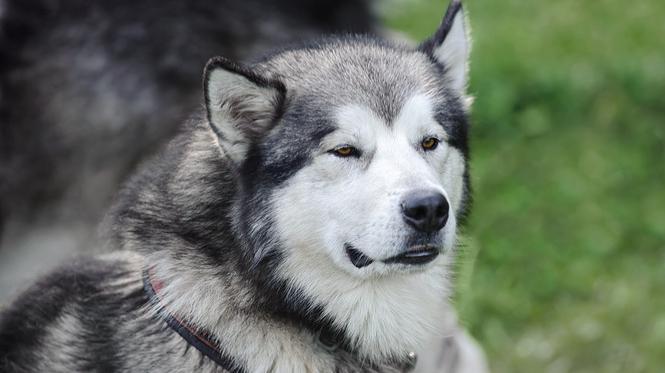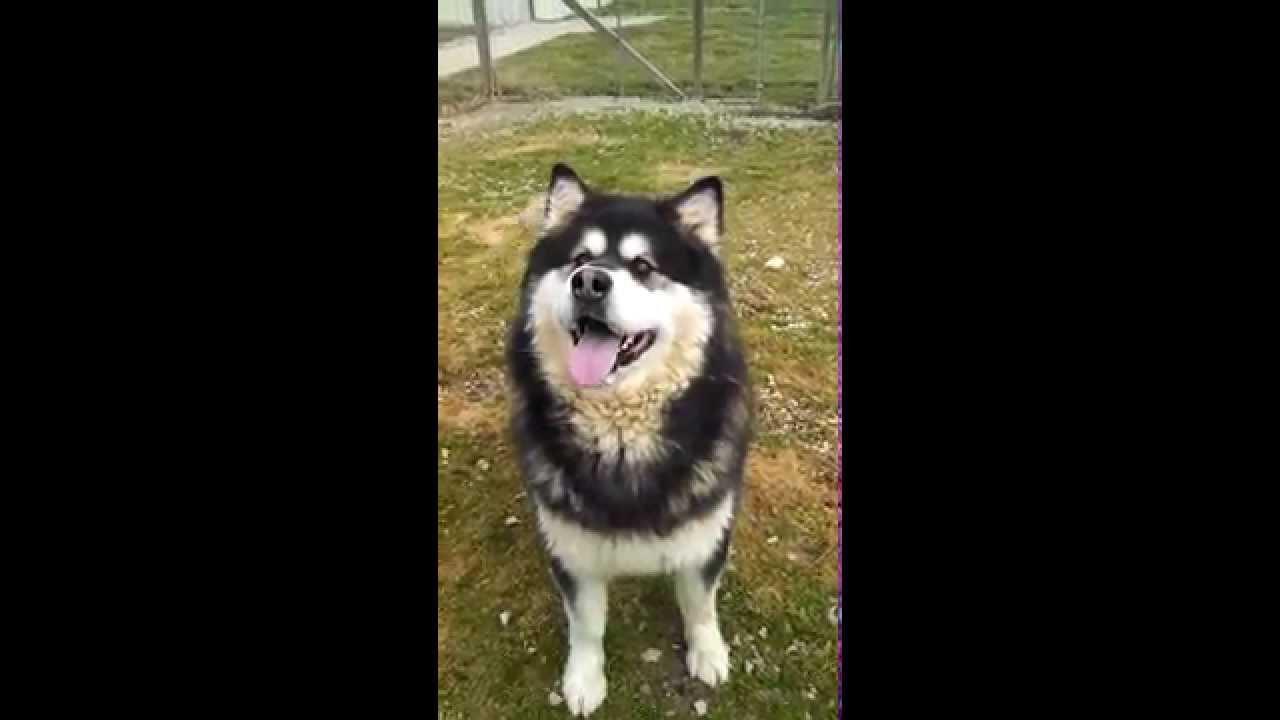The first image is the image on the left, the second image is the image on the right. Given the left and right images, does the statement "At least one dog is standing on grass." hold true? Answer yes or no. Yes. The first image is the image on the left, the second image is the image on the right. For the images displayed, is the sentence "One image shows at least one dog in a wire-covered kennel, and the other image shows a dog with 'salt and pepper' coloring on the left of a paler dog." factually correct? Answer yes or no. No. 